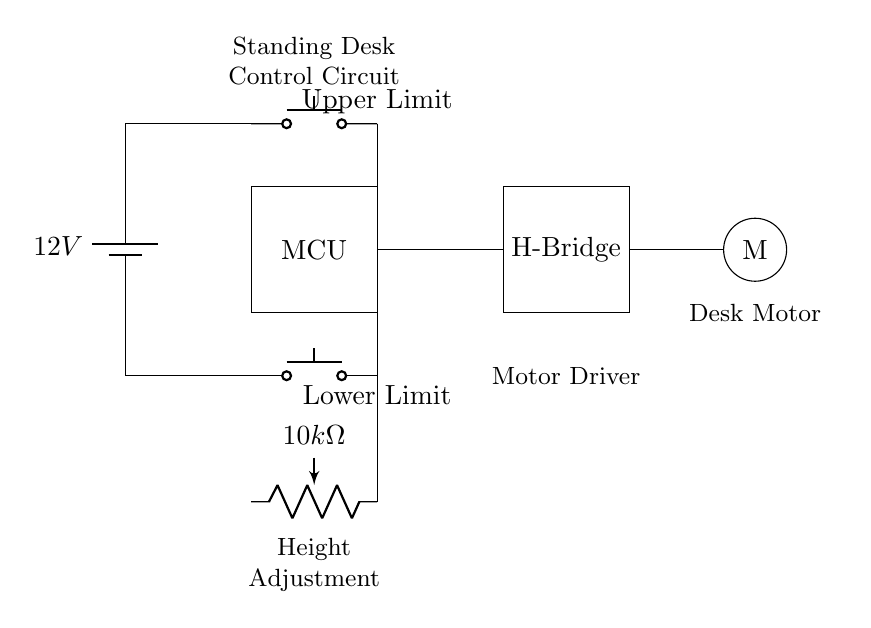What is the power supply voltage? The circuit shows a battery labeled with a voltage of 12 volts. Hence, the power supply voltage to the circuit is 12 volts.
Answer: 12 volts What component is used for height adjustment? The circuit contains a potentiometer labeled with a resistance value of 10k ohms, which is used for adjusting the height of the standing desk.
Answer: Potentiometer What controls the motor's direction? The H-Bridge in the circuit is designed to control the direction and speed of the motor by applying voltage of either polarity, thus controlling its movement.
Answer: H-Bridge How many limit switches are included? The circuit includes two push buttons labeled as Upper Limit and Lower Limit, which act as limit switches for the motor control.
Answer: Two What does the MCU stand for? In the circuit, the component labeled as MCU refers to the Microcontroller Unit, which is responsible for controlling the operation of the motor and receiving input from the limit switches.
Answer: Microcontroller What happens when the upper limit switch is pressed? When the upper limit switch is pressed, it signals the microcontroller to stop the motor to prevent over-extension of the standing desk, protecting the mechanism from damage.
Answer: Stops the motor What is the function of the motor in this circuit? The motor, marked as "M," is responsible for physically moving the standing desk up and down according to the signals received from the microcontroller and the input from the potentiometer and limit switches.
Answer: Move the desk 